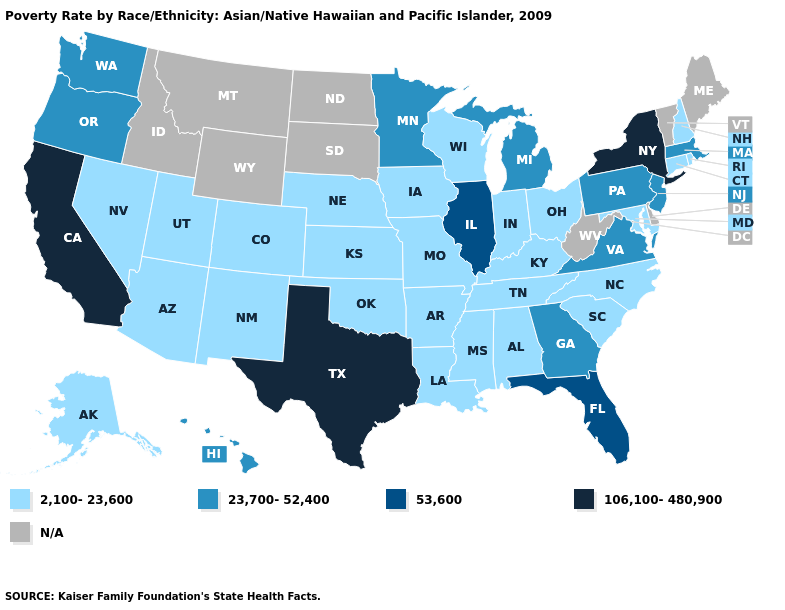Is the legend a continuous bar?
Quick response, please. No. Does the first symbol in the legend represent the smallest category?
Give a very brief answer. Yes. Does the first symbol in the legend represent the smallest category?
Keep it brief. Yes. Does Texas have the highest value in the USA?
Write a very short answer. Yes. Is the legend a continuous bar?
Short answer required. No. What is the highest value in states that border Massachusetts?
Concise answer only. 106,100-480,900. How many symbols are there in the legend?
Quick response, please. 5. Among the states that border Georgia , which have the lowest value?
Keep it brief. Alabama, North Carolina, South Carolina, Tennessee. What is the value of Louisiana?
Short answer required. 2,100-23,600. What is the value of Wisconsin?
Answer briefly. 2,100-23,600. What is the value of Indiana?
Concise answer only. 2,100-23,600. Does California have the lowest value in the West?
Short answer required. No. What is the value of Utah?
Concise answer only. 2,100-23,600. Among the states that border Mississippi , which have the lowest value?
Be succinct. Alabama, Arkansas, Louisiana, Tennessee. 